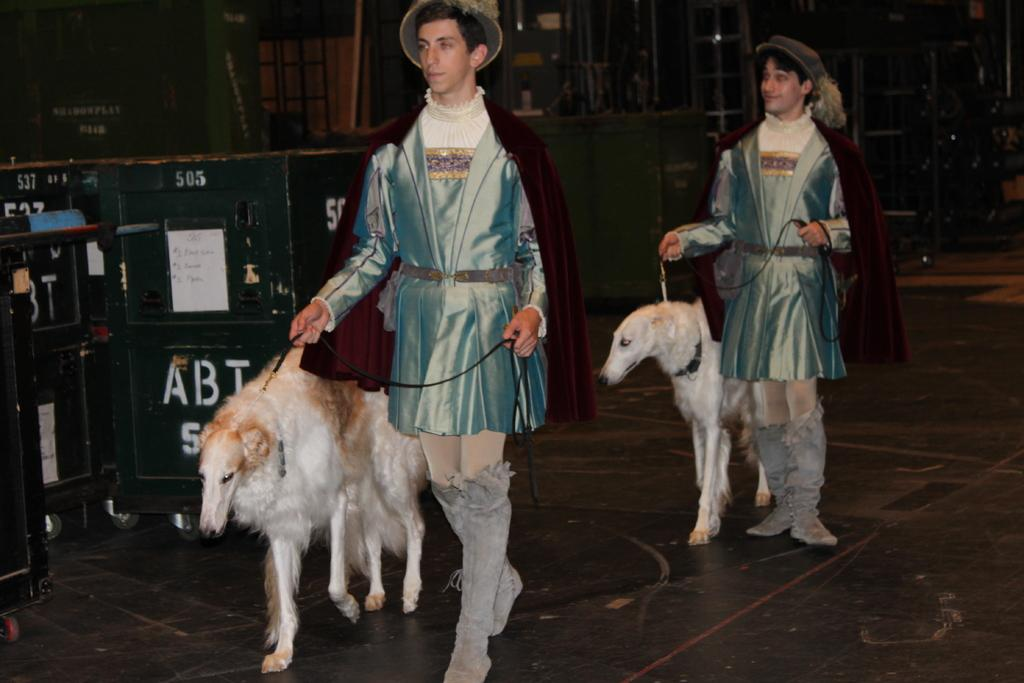How many people are in the image? There are two men in the image. What are the men wearing on their heads? The men are wearing caps. What are the men doing with the animals? The men are holding animals with the help of belts. What type of porter is carrying the jar in the image? There is no porter or jar present in the image. What theory is being discussed by the men in the image? There is no discussion or theory present in the image; the men are holding animals with the help of belts. 